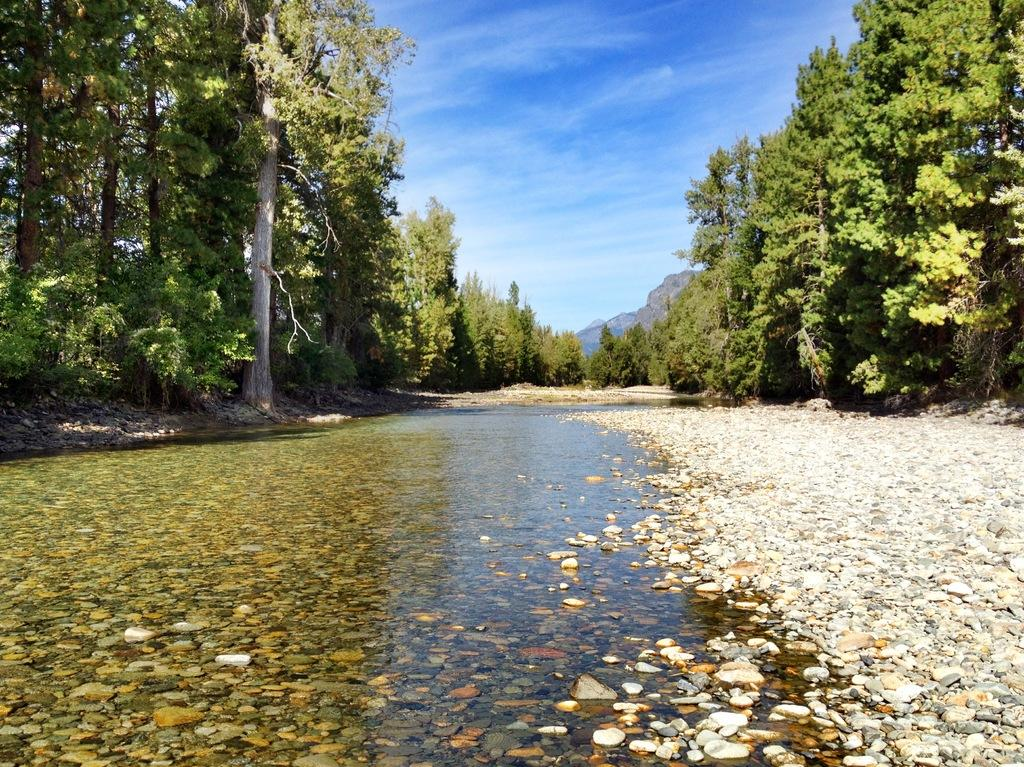What type of vegetation is present in the image? There are many trees in the image. What can be seen at the bottom of the image? There is water visible at the bottom of the image. What is in the water? There are stones in the water. What is visible in the background of the image? There is a mountain in the background of the image. What is visible at the top of the image? The sky is visible at the top of the image. What can be seen in the sky? Clouds are present in the sky. What type of corn is growing on the mountain in the image? There is no corn present in the image; it features trees, water, stones, a mountain, and clouds. What rule is being enforced by the clouds in the image? There is no rule being enforced by the clouds in the image; they are simply a natural atmospheric phenomenon. 